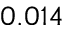Convert formula to latex. <formula><loc_0><loc_0><loc_500><loc_500>0 . 0 1 4</formula> 